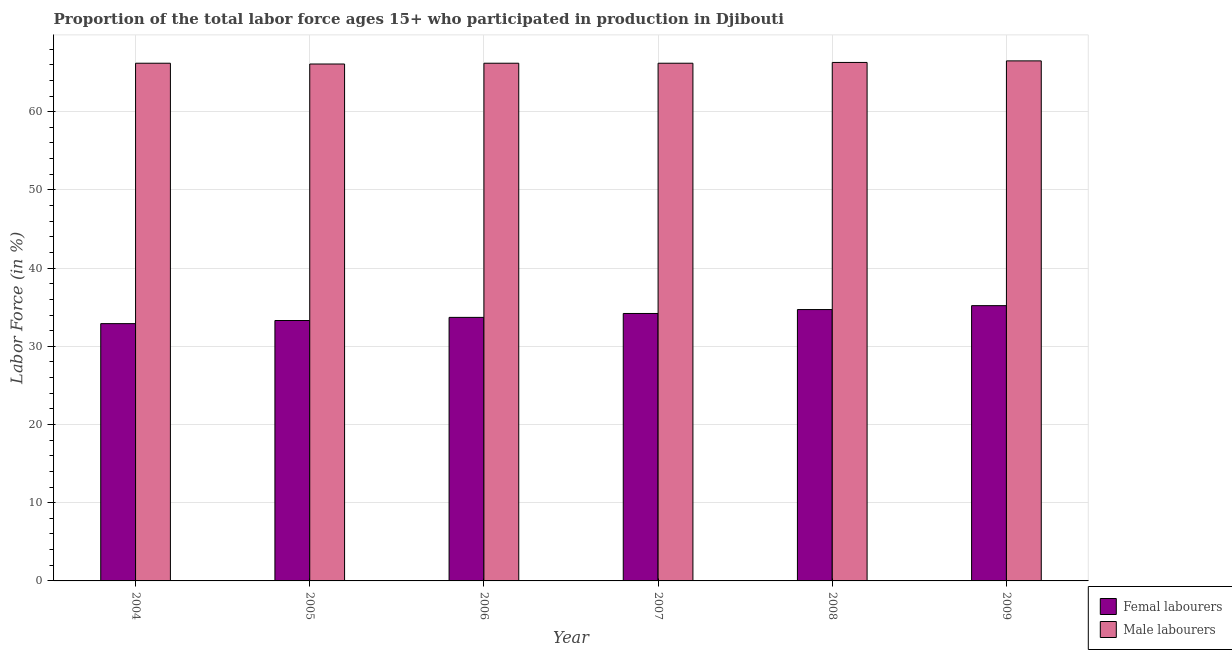How many different coloured bars are there?
Offer a terse response. 2. How many groups of bars are there?
Provide a succinct answer. 6. Are the number of bars on each tick of the X-axis equal?
Your answer should be very brief. Yes. How many bars are there on the 2nd tick from the left?
Your answer should be compact. 2. What is the label of the 6th group of bars from the left?
Give a very brief answer. 2009. What is the percentage of male labour force in 2007?
Your answer should be compact. 66.2. Across all years, what is the maximum percentage of male labour force?
Give a very brief answer. 66.5. Across all years, what is the minimum percentage of male labour force?
Give a very brief answer. 66.1. What is the total percentage of female labor force in the graph?
Your answer should be compact. 204. What is the difference between the percentage of female labor force in 2006 and that in 2009?
Your response must be concise. -1.5. What is the average percentage of male labour force per year?
Give a very brief answer. 66.25. In how many years, is the percentage of male labour force greater than 46 %?
Your response must be concise. 6. What is the ratio of the percentage of male labour force in 2004 to that in 2009?
Offer a terse response. 1. Is the percentage of female labor force in 2004 less than that in 2009?
Provide a succinct answer. Yes. What is the difference between the highest and the lowest percentage of male labour force?
Offer a very short reply. 0.4. What does the 1st bar from the left in 2007 represents?
Ensure brevity in your answer.  Femal labourers. What does the 1st bar from the right in 2006 represents?
Offer a very short reply. Male labourers. Are all the bars in the graph horizontal?
Ensure brevity in your answer.  No. Are the values on the major ticks of Y-axis written in scientific E-notation?
Your answer should be very brief. No. Does the graph contain any zero values?
Your response must be concise. No. Does the graph contain grids?
Offer a very short reply. Yes. How are the legend labels stacked?
Provide a short and direct response. Vertical. What is the title of the graph?
Ensure brevity in your answer.  Proportion of the total labor force ages 15+ who participated in production in Djibouti. What is the label or title of the X-axis?
Ensure brevity in your answer.  Year. What is the Labor Force (in %) in Femal labourers in 2004?
Keep it short and to the point. 32.9. What is the Labor Force (in %) of Male labourers in 2004?
Your answer should be compact. 66.2. What is the Labor Force (in %) of Femal labourers in 2005?
Keep it short and to the point. 33.3. What is the Labor Force (in %) in Male labourers in 2005?
Ensure brevity in your answer.  66.1. What is the Labor Force (in %) in Femal labourers in 2006?
Offer a very short reply. 33.7. What is the Labor Force (in %) of Male labourers in 2006?
Make the answer very short. 66.2. What is the Labor Force (in %) in Femal labourers in 2007?
Make the answer very short. 34.2. What is the Labor Force (in %) in Male labourers in 2007?
Give a very brief answer. 66.2. What is the Labor Force (in %) of Femal labourers in 2008?
Offer a terse response. 34.7. What is the Labor Force (in %) in Male labourers in 2008?
Ensure brevity in your answer.  66.3. What is the Labor Force (in %) of Femal labourers in 2009?
Offer a terse response. 35.2. What is the Labor Force (in %) in Male labourers in 2009?
Offer a very short reply. 66.5. Across all years, what is the maximum Labor Force (in %) of Femal labourers?
Keep it short and to the point. 35.2. Across all years, what is the maximum Labor Force (in %) in Male labourers?
Provide a short and direct response. 66.5. Across all years, what is the minimum Labor Force (in %) of Femal labourers?
Provide a short and direct response. 32.9. Across all years, what is the minimum Labor Force (in %) of Male labourers?
Give a very brief answer. 66.1. What is the total Labor Force (in %) in Femal labourers in the graph?
Provide a short and direct response. 204. What is the total Labor Force (in %) in Male labourers in the graph?
Make the answer very short. 397.5. What is the difference between the Labor Force (in %) of Male labourers in 2004 and that in 2005?
Your answer should be compact. 0.1. What is the difference between the Labor Force (in %) in Femal labourers in 2004 and that in 2006?
Provide a short and direct response. -0.8. What is the difference between the Labor Force (in %) in Femal labourers in 2004 and that in 2007?
Your answer should be very brief. -1.3. What is the difference between the Labor Force (in %) of Femal labourers in 2004 and that in 2008?
Offer a very short reply. -1.8. What is the difference between the Labor Force (in %) of Male labourers in 2004 and that in 2008?
Your response must be concise. -0.1. What is the difference between the Labor Force (in %) in Femal labourers in 2004 and that in 2009?
Ensure brevity in your answer.  -2.3. What is the difference between the Labor Force (in %) of Male labourers in 2004 and that in 2009?
Offer a terse response. -0.3. What is the difference between the Labor Force (in %) of Femal labourers in 2005 and that in 2006?
Your response must be concise. -0.4. What is the difference between the Labor Force (in %) in Male labourers in 2005 and that in 2006?
Ensure brevity in your answer.  -0.1. What is the difference between the Labor Force (in %) in Femal labourers in 2005 and that in 2007?
Ensure brevity in your answer.  -0.9. What is the difference between the Labor Force (in %) in Male labourers in 2006 and that in 2007?
Your response must be concise. 0. What is the difference between the Labor Force (in %) in Femal labourers in 2006 and that in 2009?
Your response must be concise. -1.5. What is the difference between the Labor Force (in %) of Male labourers in 2006 and that in 2009?
Offer a terse response. -0.3. What is the difference between the Labor Force (in %) of Femal labourers in 2007 and that in 2008?
Make the answer very short. -0.5. What is the difference between the Labor Force (in %) of Male labourers in 2007 and that in 2008?
Your answer should be compact. -0.1. What is the difference between the Labor Force (in %) in Femal labourers in 2008 and that in 2009?
Your answer should be compact. -0.5. What is the difference between the Labor Force (in %) in Male labourers in 2008 and that in 2009?
Offer a terse response. -0.2. What is the difference between the Labor Force (in %) in Femal labourers in 2004 and the Labor Force (in %) in Male labourers in 2005?
Your answer should be very brief. -33.2. What is the difference between the Labor Force (in %) of Femal labourers in 2004 and the Labor Force (in %) of Male labourers in 2006?
Your answer should be very brief. -33.3. What is the difference between the Labor Force (in %) of Femal labourers in 2004 and the Labor Force (in %) of Male labourers in 2007?
Your answer should be very brief. -33.3. What is the difference between the Labor Force (in %) of Femal labourers in 2004 and the Labor Force (in %) of Male labourers in 2008?
Keep it short and to the point. -33.4. What is the difference between the Labor Force (in %) of Femal labourers in 2004 and the Labor Force (in %) of Male labourers in 2009?
Ensure brevity in your answer.  -33.6. What is the difference between the Labor Force (in %) in Femal labourers in 2005 and the Labor Force (in %) in Male labourers in 2006?
Make the answer very short. -32.9. What is the difference between the Labor Force (in %) in Femal labourers in 2005 and the Labor Force (in %) in Male labourers in 2007?
Your answer should be very brief. -32.9. What is the difference between the Labor Force (in %) in Femal labourers in 2005 and the Labor Force (in %) in Male labourers in 2008?
Your response must be concise. -33. What is the difference between the Labor Force (in %) in Femal labourers in 2005 and the Labor Force (in %) in Male labourers in 2009?
Offer a terse response. -33.2. What is the difference between the Labor Force (in %) of Femal labourers in 2006 and the Labor Force (in %) of Male labourers in 2007?
Keep it short and to the point. -32.5. What is the difference between the Labor Force (in %) of Femal labourers in 2006 and the Labor Force (in %) of Male labourers in 2008?
Give a very brief answer. -32.6. What is the difference between the Labor Force (in %) of Femal labourers in 2006 and the Labor Force (in %) of Male labourers in 2009?
Ensure brevity in your answer.  -32.8. What is the difference between the Labor Force (in %) of Femal labourers in 2007 and the Labor Force (in %) of Male labourers in 2008?
Ensure brevity in your answer.  -32.1. What is the difference between the Labor Force (in %) in Femal labourers in 2007 and the Labor Force (in %) in Male labourers in 2009?
Offer a terse response. -32.3. What is the difference between the Labor Force (in %) of Femal labourers in 2008 and the Labor Force (in %) of Male labourers in 2009?
Make the answer very short. -31.8. What is the average Labor Force (in %) in Male labourers per year?
Ensure brevity in your answer.  66.25. In the year 2004, what is the difference between the Labor Force (in %) of Femal labourers and Labor Force (in %) of Male labourers?
Give a very brief answer. -33.3. In the year 2005, what is the difference between the Labor Force (in %) in Femal labourers and Labor Force (in %) in Male labourers?
Offer a very short reply. -32.8. In the year 2006, what is the difference between the Labor Force (in %) in Femal labourers and Labor Force (in %) in Male labourers?
Ensure brevity in your answer.  -32.5. In the year 2007, what is the difference between the Labor Force (in %) of Femal labourers and Labor Force (in %) of Male labourers?
Your answer should be very brief. -32. In the year 2008, what is the difference between the Labor Force (in %) in Femal labourers and Labor Force (in %) in Male labourers?
Your answer should be very brief. -31.6. In the year 2009, what is the difference between the Labor Force (in %) in Femal labourers and Labor Force (in %) in Male labourers?
Provide a short and direct response. -31.3. What is the ratio of the Labor Force (in %) of Femal labourers in 2004 to that in 2005?
Your answer should be compact. 0.99. What is the ratio of the Labor Force (in %) in Femal labourers in 2004 to that in 2006?
Provide a short and direct response. 0.98. What is the ratio of the Labor Force (in %) in Male labourers in 2004 to that in 2006?
Ensure brevity in your answer.  1. What is the ratio of the Labor Force (in %) of Male labourers in 2004 to that in 2007?
Your response must be concise. 1. What is the ratio of the Labor Force (in %) in Femal labourers in 2004 to that in 2008?
Your answer should be compact. 0.95. What is the ratio of the Labor Force (in %) of Femal labourers in 2004 to that in 2009?
Make the answer very short. 0.93. What is the ratio of the Labor Force (in %) in Femal labourers in 2005 to that in 2006?
Offer a terse response. 0.99. What is the ratio of the Labor Force (in %) of Male labourers in 2005 to that in 2006?
Provide a succinct answer. 1. What is the ratio of the Labor Force (in %) in Femal labourers in 2005 to that in 2007?
Keep it short and to the point. 0.97. What is the ratio of the Labor Force (in %) in Male labourers in 2005 to that in 2007?
Your answer should be compact. 1. What is the ratio of the Labor Force (in %) of Femal labourers in 2005 to that in 2008?
Offer a very short reply. 0.96. What is the ratio of the Labor Force (in %) in Femal labourers in 2005 to that in 2009?
Offer a very short reply. 0.95. What is the ratio of the Labor Force (in %) in Femal labourers in 2006 to that in 2007?
Offer a very short reply. 0.99. What is the ratio of the Labor Force (in %) of Femal labourers in 2006 to that in 2008?
Make the answer very short. 0.97. What is the ratio of the Labor Force (in %) of Femal labourers in 2006 to that in 2009?
Your response must be concise. 0.96. What is the ratio of the Labor Force (in %) in Femal labourers in 2007 to that in 2008?
Your answer should be very brief. 0.99. What is the ratio of the Labor Force (in %) in Femal labourers in 2007 to that in 2009?
Offer a very short reply. 0.97. What is the ratio of the Labor Force (in %) of Femal labourers in 2008 to that in 2009?
Make the answer very short. 0.99. What is the ratio of the Labor Force (in %) in Male labourers in 2008 to that in 2009?
Provide a succinct answer. 1. What is the difference between the highest and the lowest Labor Force (in %) of Femal labourers?
Make the answer very short. 2.3. What is the difference between the highest and the lowest Labor Force (in %) of Male labourers?
Your answer should be compact. 0.4. 